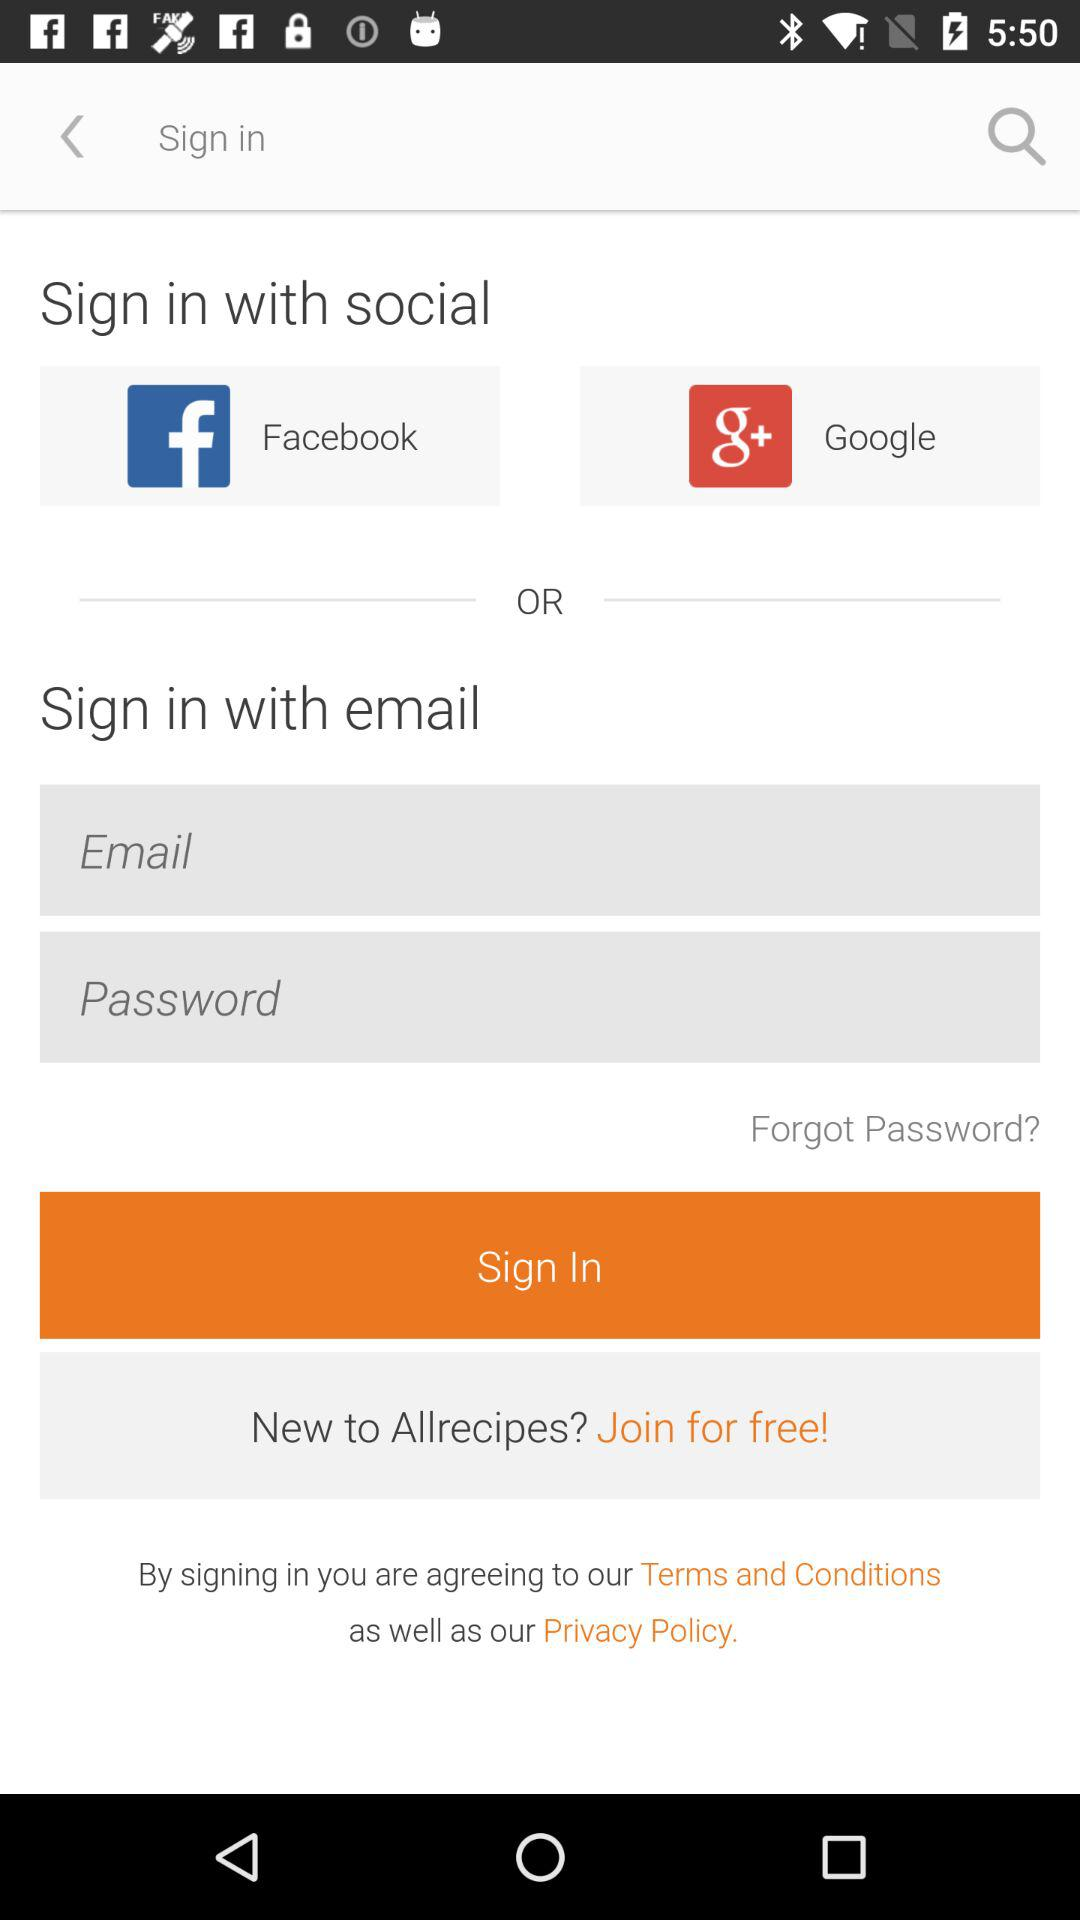What accounts can I use to sign in? You can use "Facebook", "Google" and "email" to sign in. 